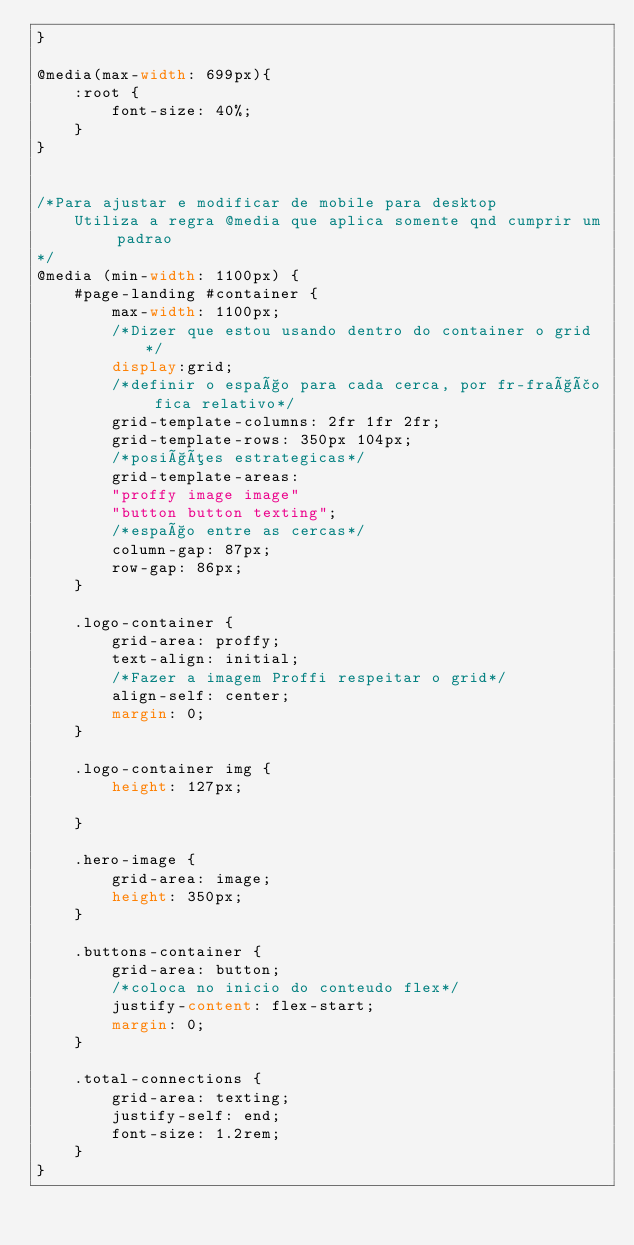<code> <loc_0><loc_0><loc_500><loc_500><_CSS_>}

@media(max-width: 699px){
    :root {
        font-size: 40%;
    }
}


/*Para ajustar e modificar de mobile para desktop
    Utiliza a regra @media que aplica somente qnd cumprir um padrao
*/
@media (min-width: 1100px) {
    #page-landing #container {
        max-width: 1100px;
        /*Dizer que estou usando dentro do container o grid*/
        display:grid;
        /*definir o espaço para cada cerca, por fr-fração fica relativo*/
        grid-template-columns: 2fr 1fr 2fr;
        grid-template-rows: 350px 104px;
        /*posições estrategicas*/
        grid-template-areas:
        "proffy image image"
        "button button texting";
        /*espaço entre as cercas*/
        column-gap: 87px;
        row-gap: 86px;
    }

    .logo-container {
        grid-area: proffy;
        text-align: initial;
        /*Fazer a imagem Proffi respeitar o grid*/
        align-self: center;
        margin: 0;
    }

    .logo-container img {
        height: 127px;

    }

    .hero-image {
        grid-area: image;
        height: 350px;
    }

    .buttons-container {
        grid-area: button;
        /*coloca no inicio do conteudo flex*/
        justify-content: flex-start;
        margin: 0;
    }

    .total-connections {
        grid-area: texting;
        justify-self: end;
        font-size: 1.2rem;
    }
}</code> 